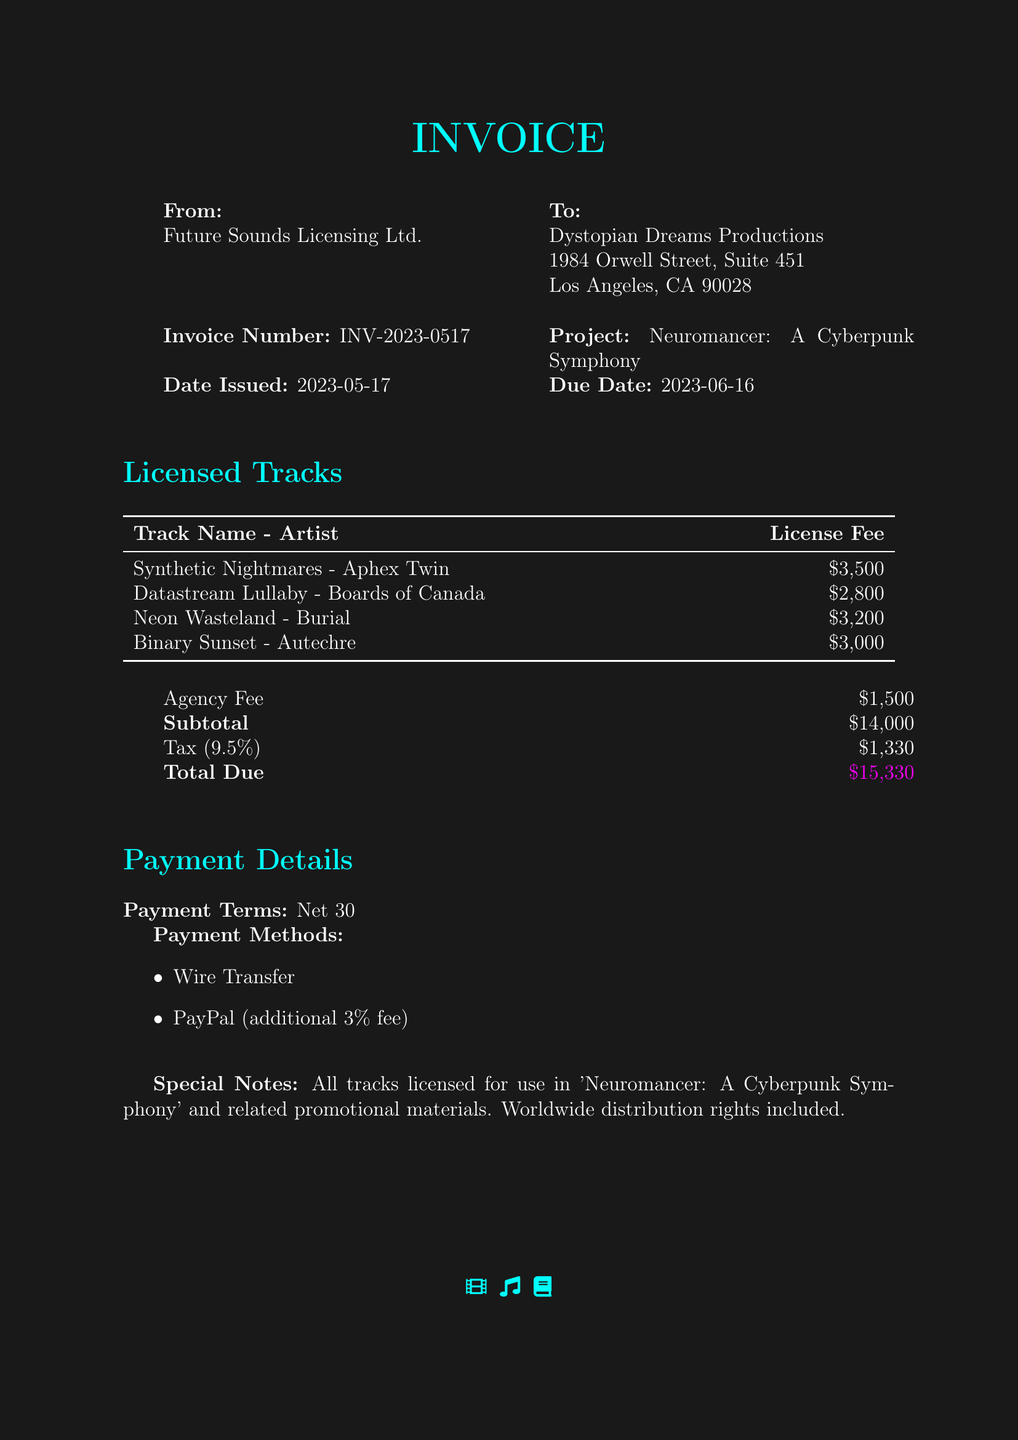what is the invoice number? The invoice number is specified in the document as a unique identifier for the billing, which is INV-2023-0517.
Answer: INV-2023-0517 who is the issuer of the invoice? The issuer of the invoice is Future Sounds Licensing Ltd., as mentioned at the top of the document.
Answer: Future Sounds Licensing Ltd what is the due date for the invoice? The due date is provided to ensure timely payment and is stated as 2023-06-16.
Answer: 2023-06-16 how many tracks are listed in the invoice? The invoice lists a total of four licensed tracks that are detailed in the section provided.
Answer: Four what is the subtotal amount before tax? The subtotal is the sum of all license fees and the agency fee before applying tax, which is clearly stated in the document.
Answer: $14,000 what percentage is the sales tax applied? The document specifies that a tax rate of 9.5% is applied to the subtotal for calculating the total due.
Answer: 9.5% what is the total amount due? The total amount that is due after including tax is given at the bottom of the invoice, representing the final billing amount.
Answer: $15,330 what payment terms are specified? The payment terms that dictate the requirements for payment timing are outlined in the document, indicating when payment is expected.
Answer: Net 30 which payment methods are offered? The document lists the available methods for making payment, indicating flexibility for the client in choosing how to pay.
Answer: Wire Transfer, PayPal 